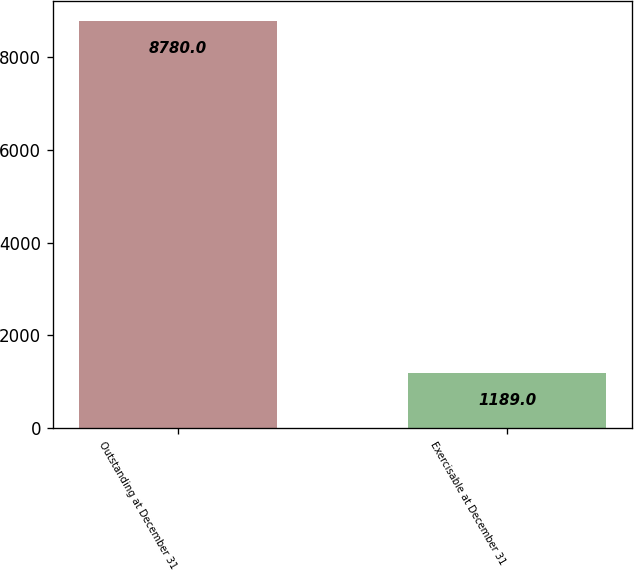<chart> <loc_0><loc_0><loc_500><loc_500><bar_chart><fcel>Outstanding at December 31<fcel>Exercisable at December 31<nl><fcel>8780<fcel>1189<nl></chart> 